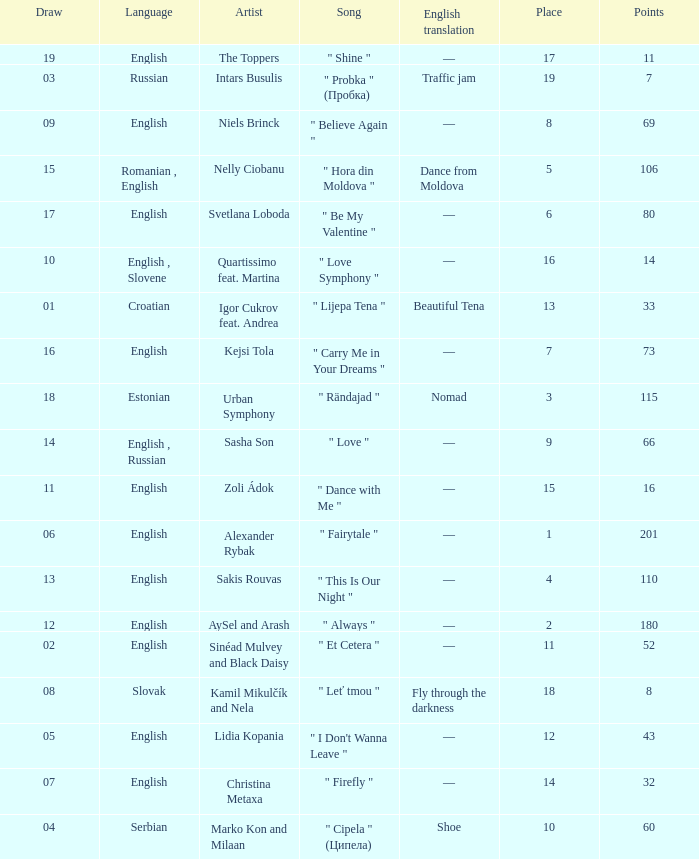What is the average Points when the artist is kamil mikulčík and nela, and the Place is larger than 18? None. 